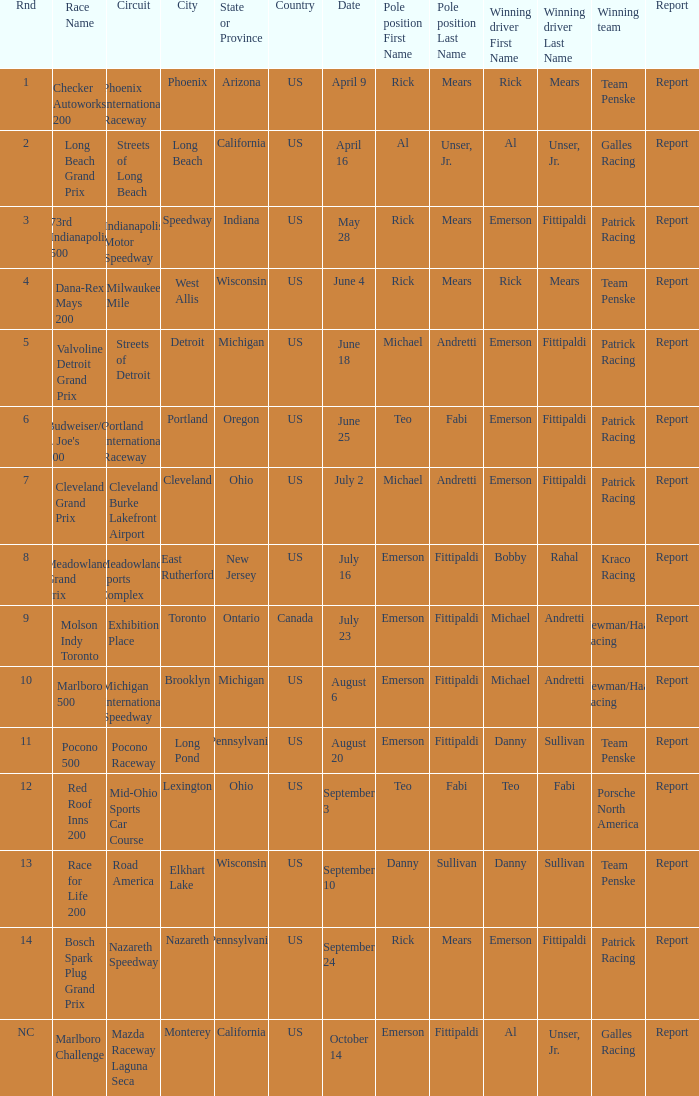Who was the pole position for the rnd equalling 12? Teo Fabi. 